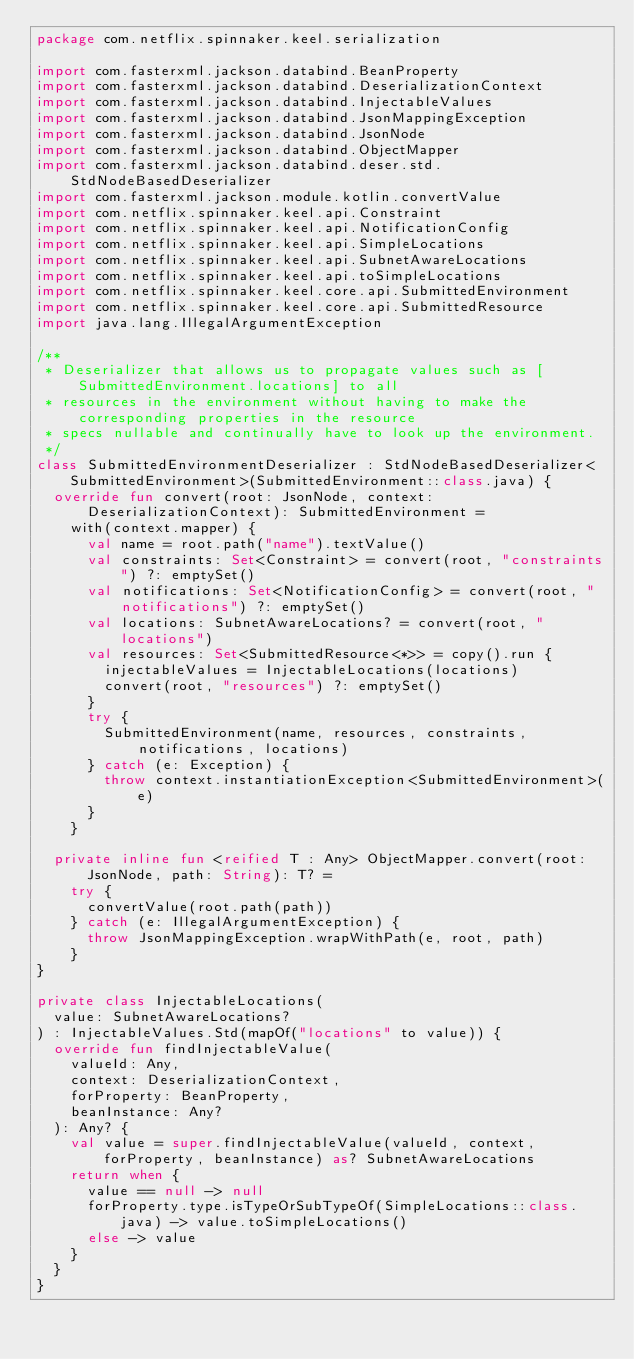Convert code to text. <code><loc_0><loc_0><loc_500><loc_500><_Kotlin_>package com.netflix.spinnaker.keel.serialization

import com.fasterxml.jackson.databind.BeanProperty
import com.fasterxml.jackson.databind.DeserializationContext
import com.fasterxml.jackson.databind.InjectableValues
import com.fasterxml.jackson.databind.JsonMappingException
import com.fasterxml.jackson.databind.JsonNode
import com.fasterxml.jackson.databind.ObjectMapper
import com.fasterxml.jackson.databind.deser.std.StdNodeBasedDeserializer
import com.fasterxml.jackson.module.kotlin.convertValue
import com.netflix.spinnaker.keel.api.Constraint
import com.netflix.spinnaker.keel.api.NotificationConfig
import com.netflix.spinnaker.keel.api.SimpleLocations
import com.netflix.spinnaker.keel.api.SubnetAwareLocations
import com.netflix.spinnaker.keel.api.toSimpleLocations
import com.netflix.spinnaker.keel.core.api.SubmittedEnvironment
import com.netflix.spinnaker.keel.core.api.SubmittedResource
import java.lang.IllegalArgumentException

/**
 * Deserializer that allows us to propagate values such as [SubmittedEnvironment.locations] to all
 * resources in the environment without having to make the corresponding properties in the resource
 * specs nullable and continually have to look up the environment.
 */
class SubmittedEnvironmentDeserializer : StdNodeBasedDeserializer<SubmittedEnvironment>(SubmittedEnvironment::class.java) {
  override fun convert(root: JsonNode, context: DeserializationContext): SubmittedEnvironment =
    with(context.mapper) {
      val name = root.path("name").textValue()
      val constraints: Set<Constraint> = convert(root, "constraints") ?: emptySet()
      val notifications: Set<NotificationConfig> = convert(root, "notifications") ?: emptySet()
      val locations: SubnetAwareLocations? = convert(root, "locations")
      val resources: Set<SubmittedResource<*>> = copy().run {
        injectableValues = InjectableLocations(locations)
        convert(root, "resources") ?: emptySet()
      }
      try {
        SubmittedEnvironment(name, resources, constraints, notifications, locations)
      } catch (e: Exception) {
        throw context.instantiationException<SubmittedEnvironment>(e)
      }
    }

  private inline fun <reified T : Any> ObjectMapper.convert(root: JsonNode, path: String): T? =
    try {
      convertValue(root.path(path))
    } catch (e: IllegalArgumentException) {
      throw JsonMappingException.wrapWithPath(e, root, path)
    }
}

private class InjectableLocations(
  value: SubnetAwareLocations?
) : InjectableValues.Std(mapOf("locations" to value)) {
  override fun findInjectableValue(
    valueId: Any,
    context: DeserializationContext,
    forProperty: BeanProperty,
    beanInstance: Any?
  ): Any? {
    val value = super.findInjectableValue(valueId, context, forProperty, beanInstance) as? SubnetAwareLocations
    return when {
      value == null -> null
      forProperty.type.isTypeOrSubTypeOf(SimpleLocations::class.java) -> value.toSimpleLocations()
      else -> value
    }
  }
}
</code> 